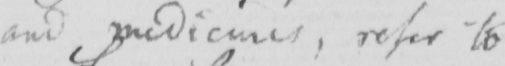Please provide the text content of this handwritten line. and medicines , refer to 